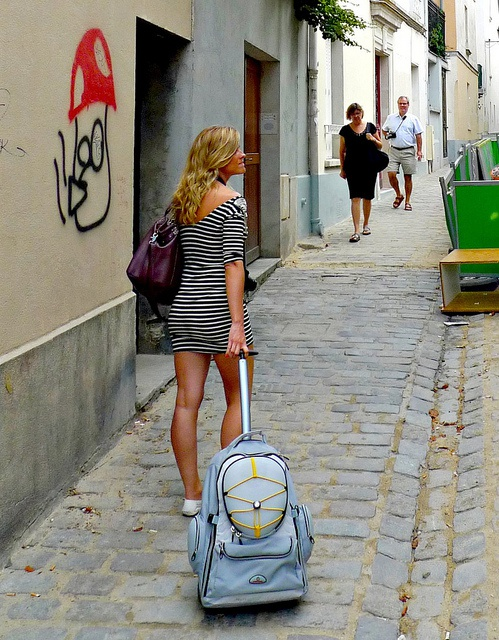Describe the objects in this image and their specific colors. I can see people in darkgray, black, brown, and maroon tones, suitcase in darkgray, gray, and lightblue tones, handbag in darkgray, black, purple, and gray tones, people in darkgray, black, maroon, brown, and gray tones, and people in darkgray, lightgray, maroon, and gray tones in this image. 